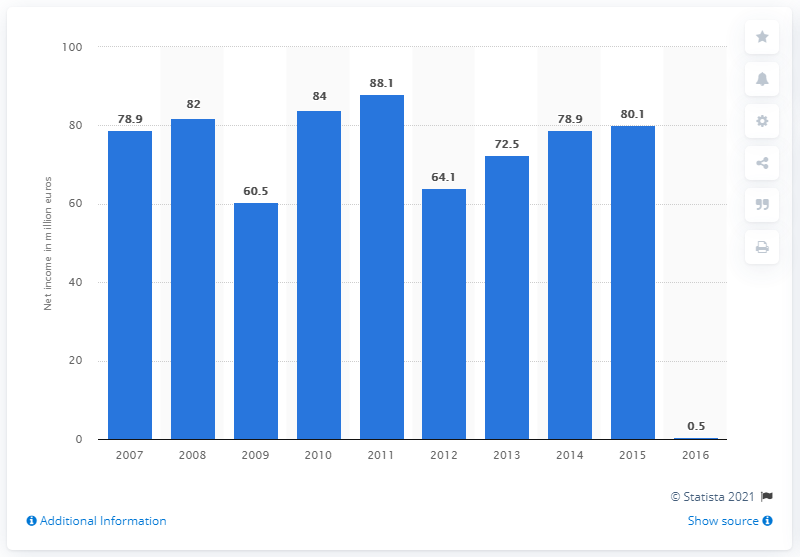Draw attention to some important aspects in this diagram. GfK's net income in 2015 was 80.1 million US dollars. 